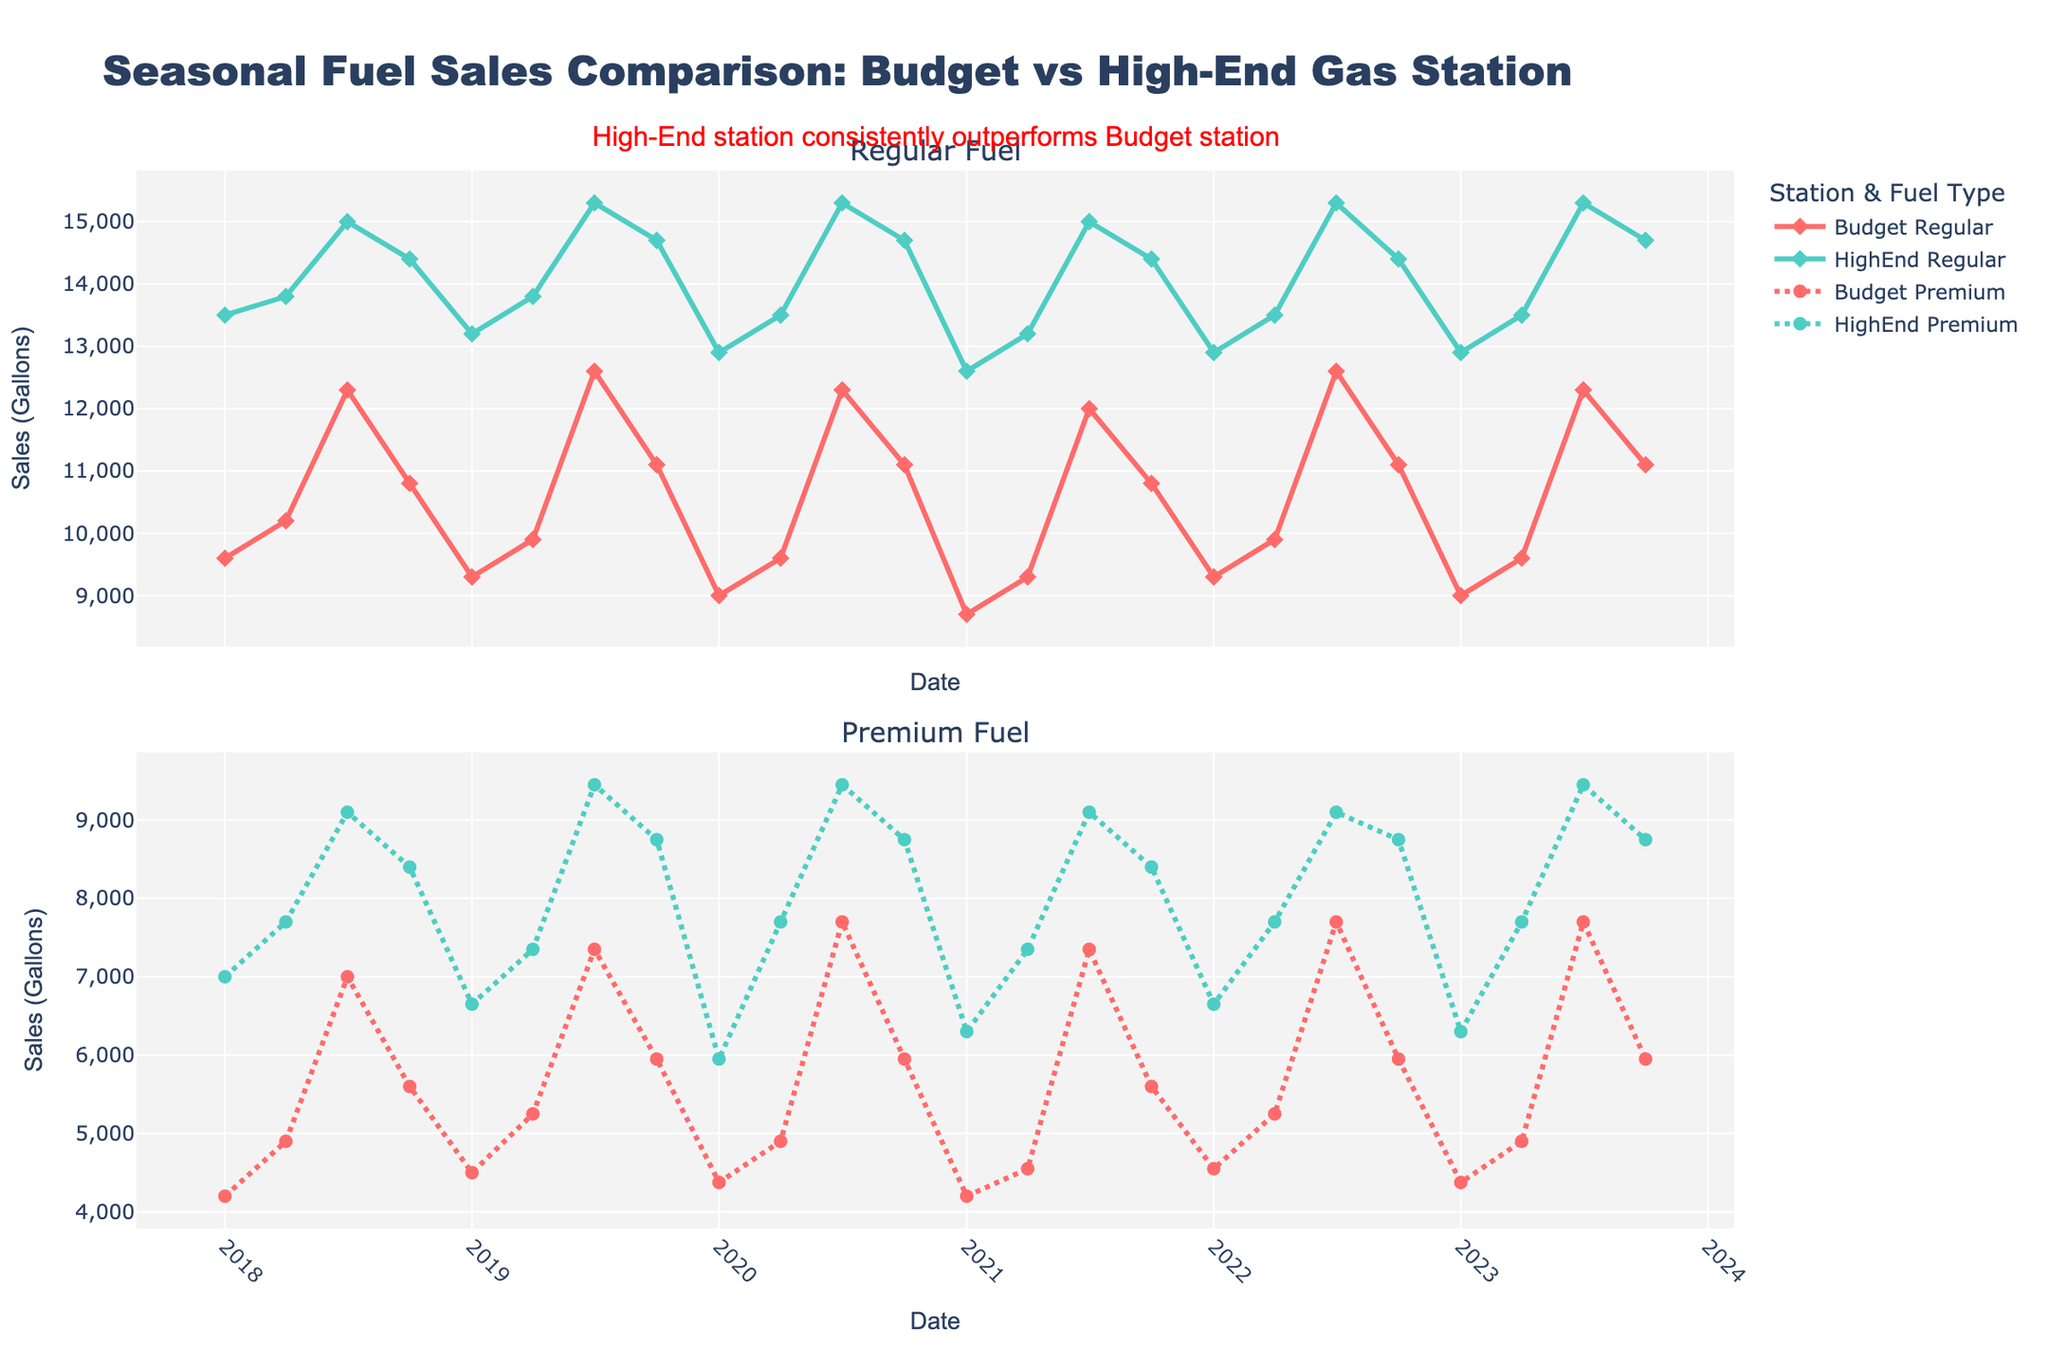How does the sales volume for regular fuel compare between Budget and High-End stations in any given season? Look at the lines representing Regular fuel for both Budget and High-End stations within each season. Compare their Y-values representing sales volume in gallons. For instance, during any summer season (July), High-End always has higher sales than Budget.
Answer: High-End has consistently higher sales Between which years did the Budget gas station see the highest sales for regular fuel, and how much was it? Look at the Regular fuel subplot, follow the Budget line (red) over the years, and identify the peak. The highest point is in the summer of 2019 (July), with sales of 4,200 gallons.
Answer: 2019, 4,200 gallons What is the general trend of Premium fuel sales at the High-End station over the five-year period? Look at the Premium fuel subplot, follow the High-End line (green, dotted). The general trend shows an increase with seasonal peaks and troughs.
Answer: Increasing trend In which season does the High-End station consistently outperform the Budget station for Premium fuel sales? Compare the Premium fuel subplot for both stations across all seasons. High-End consistently outperforms Budget in summer (July).
Answer: Summer (July) What's the difference in sales volume between Budget and High-End stations for regular fuel in the summer of 2021? Find the points for both Budget and High-End for July 2021. Sales for Budget are 4,000 gallons, while for High-End are 5,000 gallons. The difference is 5,000 - 4,000 = 1,000 gallons.
Answer: 1,000 gallons What is the most noticeable seasonal pattern in regular fuel sales? Look at the regular fuel sales for both stations, and see if any particular season consistently shows a peak or trough. Regular fuel sales peak in summer (July) for both stations.
Answer: Peak in summer Which station showed more stability in Premium fuel sales, Budget or High-End, and how can you tell? Examine the Premium fuel subplot for both stations. Stability can be inferred by observing less variability (flatter line). Budget (red, dotted) shows more consistent sales levels compared to High-End's variability.
Answer: Budget is more stable Do both stations have the same peak season for Premium fuel sales, and if so, which season is it? Identify the peak points for Premium fuel sales in both Budget and High-End stations over the years. Both stations peak in summer (July).
Answer: Yes, summer (July) Are the sales trends for regular fuel and Premium fuel similar within each station? Evaluate the trends in both subplots for each station. Look for patterns like increases, decreases, or consistency. Both stations show similar seasonal patterns (peaks in summer) for both Regular and Premium fuel.
Answer: Yes, similar trends By how much do High-End station sales for Premium fuel exceed Budget station sales in the first quarter of 2023? Check the Premium fuel sales for both stations in January 2023. Budget is at 1,250 gallons, and High-End is at 1,800 gallons. The difference is 1,800 - 1,250 = 550 gallons.
Answer: 550 gallons 